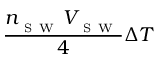Convert formula to latex. <formula><loc_0><loc_0><loc_500><loc_500>\frac { n _ { _ { S W } } V _ { _ { S W } } } { 4 } \Delta T</formula> 